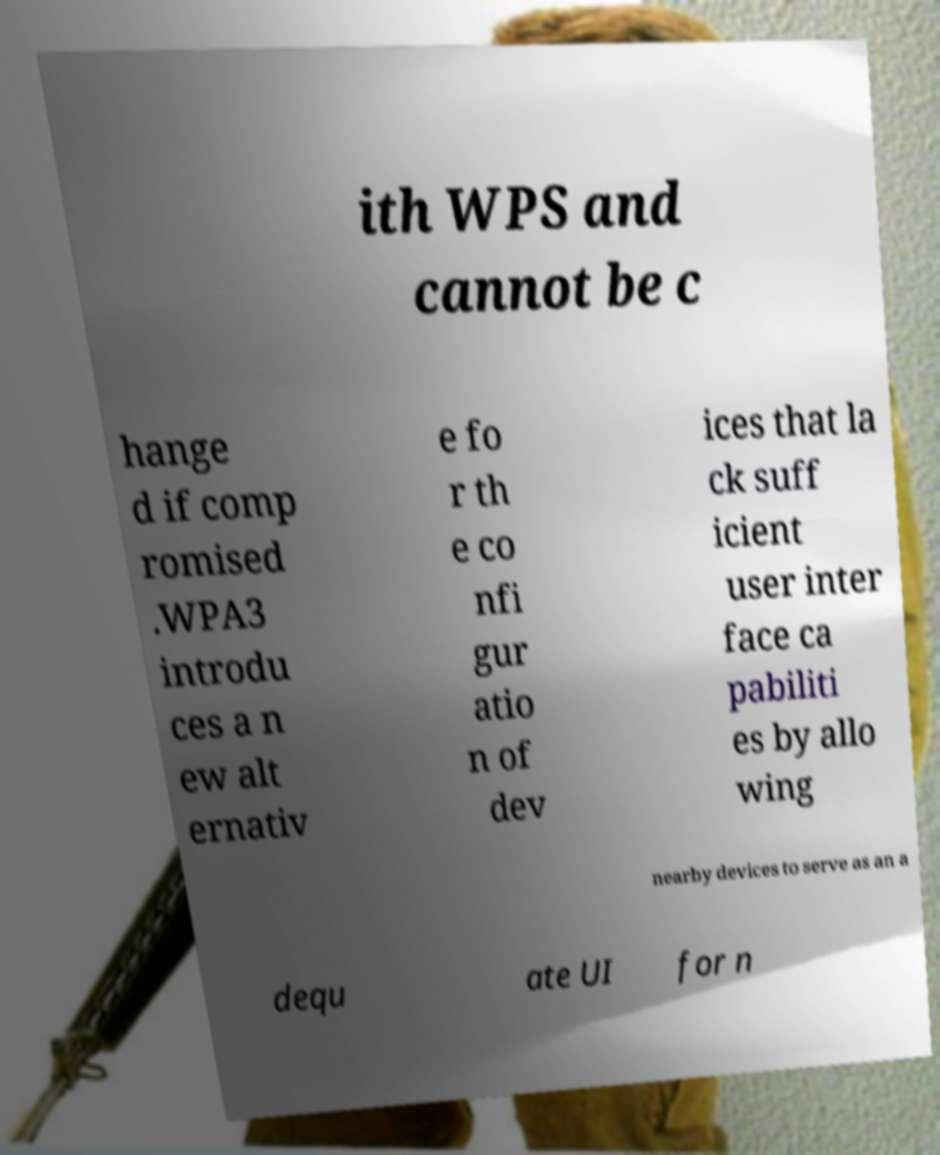Please identify and transcribe the text found in this image. ith WPS and cannot be c hange d if comp romised .WPA3 introdu ces a n ew alt ernativ e fo r th e co nfi gur atio n of dev ices that la ck suff icient user inter face ca pabiliti es by allo wing nearby devices to serve as an a dequ ate UI for n 